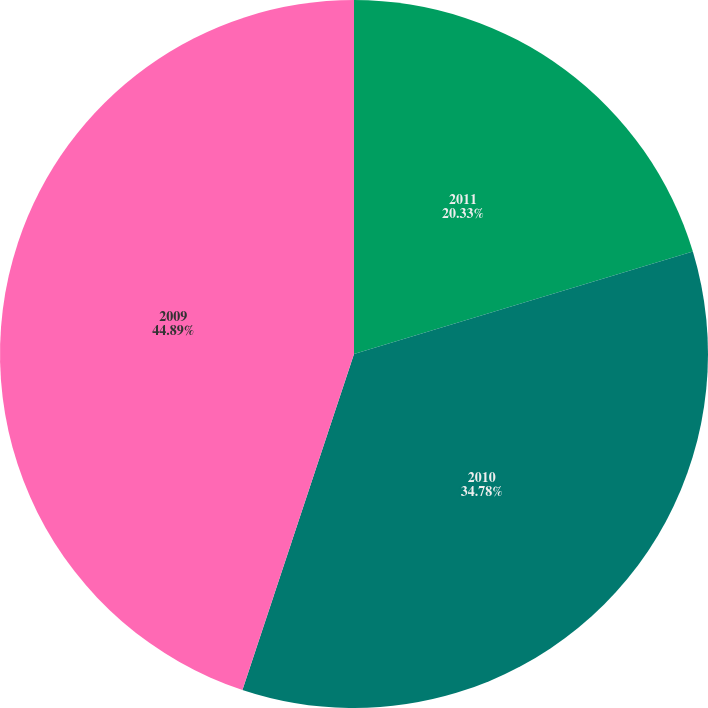<chart> <loc_0><loc_0><loc_500><loc_500><pie_chart><fcel>2011<fcel>2010<fcel>2009<nl><fcel>20.33%<fcel>34.78%<fcel>44.9%<nl></chart> 